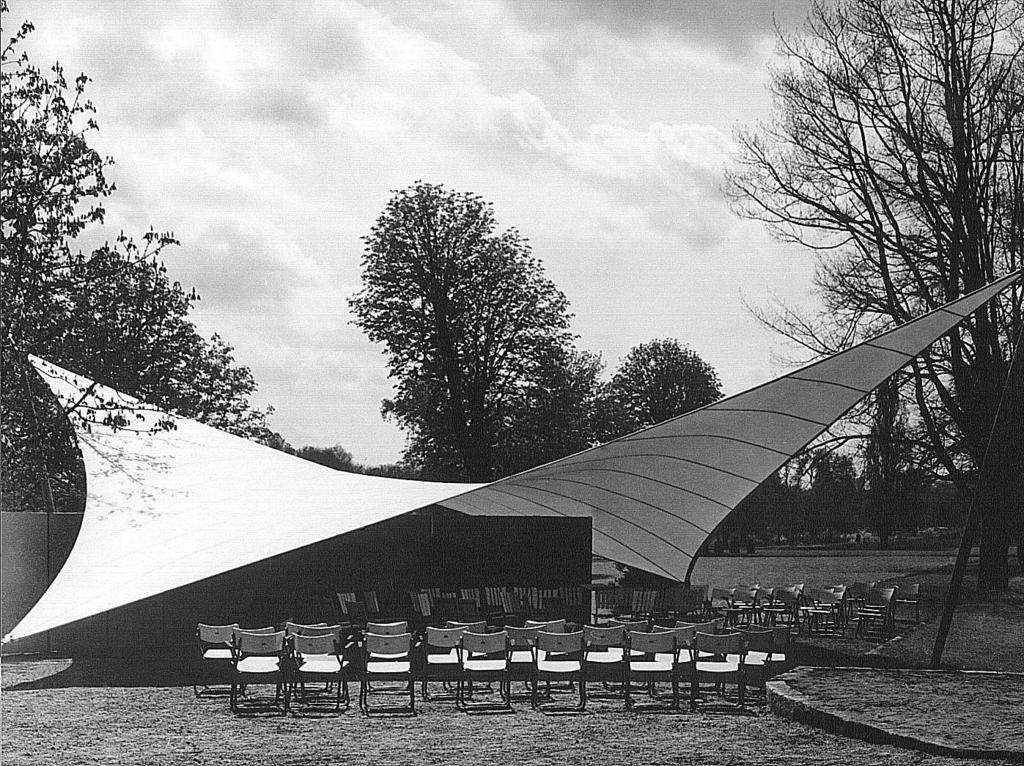What type of structure is present in the image? There is a white color canopy shed in the image. How are the chairs arranged in the image? Many chairs are placed on the ground in the image. What can be seen in the background of the image? There are dry trees visible in the background of the image. What is the condition of the sky in the image? The sky is clear and visible in the image. What type of vegetable is being served to the queen in the image? There is no queen or vegetable present in the image. Is the image taken during the winter season? The provided facts do not mention the season, so it cannot be determined if the image was taken during winter. 